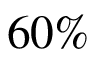<formula> <loc_0><loc_0><loc_500><loc_500>6 0 \%</formula> 